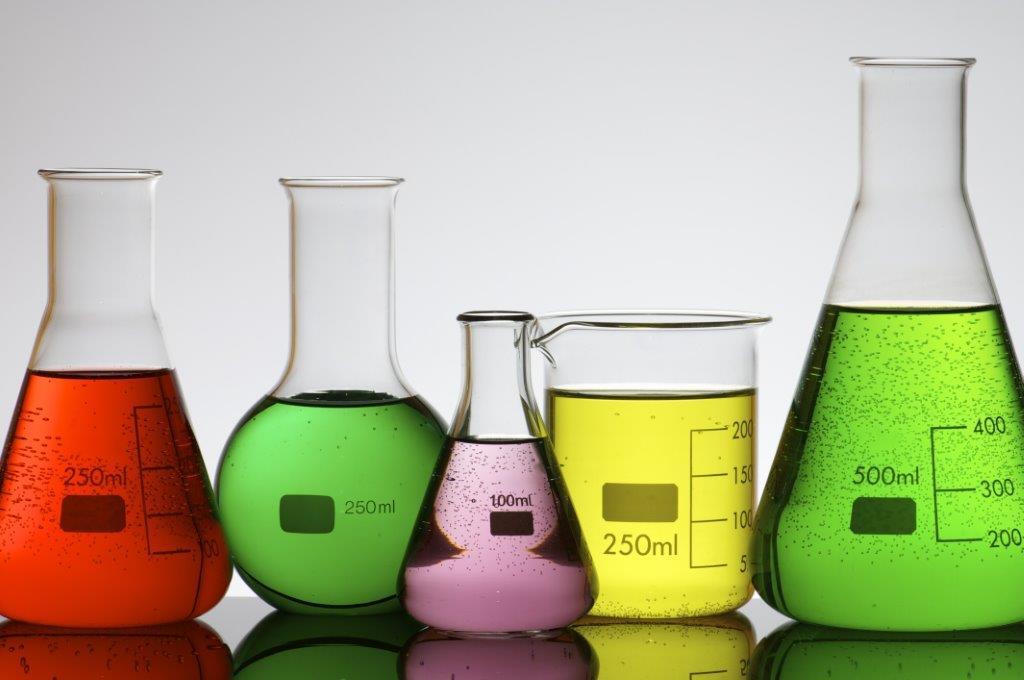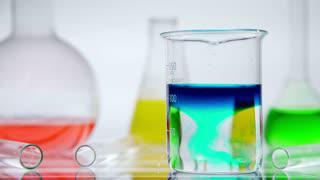The first image is the image on the left, the second image is the image on the right. Assess this claim about the two images: "One image shows exactly five containers of liquid in varying sizes and includes the colors green, yellow, and purple.". Correct or not? Answer yes or no. Yes. The first image is the image on the left, the second image is the image on the right. Analyze the images presented: Is the assertion "All of the upright beakers of various shapes contain colored liquids." valid? Answer yes or no. Yes. 